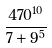Convert formula to latex. <formula><loc_0><loc_0><loc_500><loc_500>\frac { 4 7 0 ^ { 1 0 } } { 7 + 9 ^ { 5 } }</formula> 